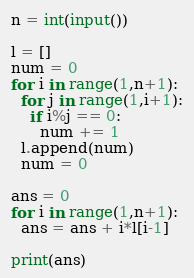<code> <loc_0><loc_0><loc_500><loc_500><_Python_>n = int(input())

l = []
num = 0
for i in range(1,n+1):
  for j in range(1,i+1):
    if i%j == 0:
      num += 1
  l.append(num)
  num = 0
  
ans = 0
for i in range(1,n+1):
  ans = ans + i*l[i-1]
  
print(ans)</code> 